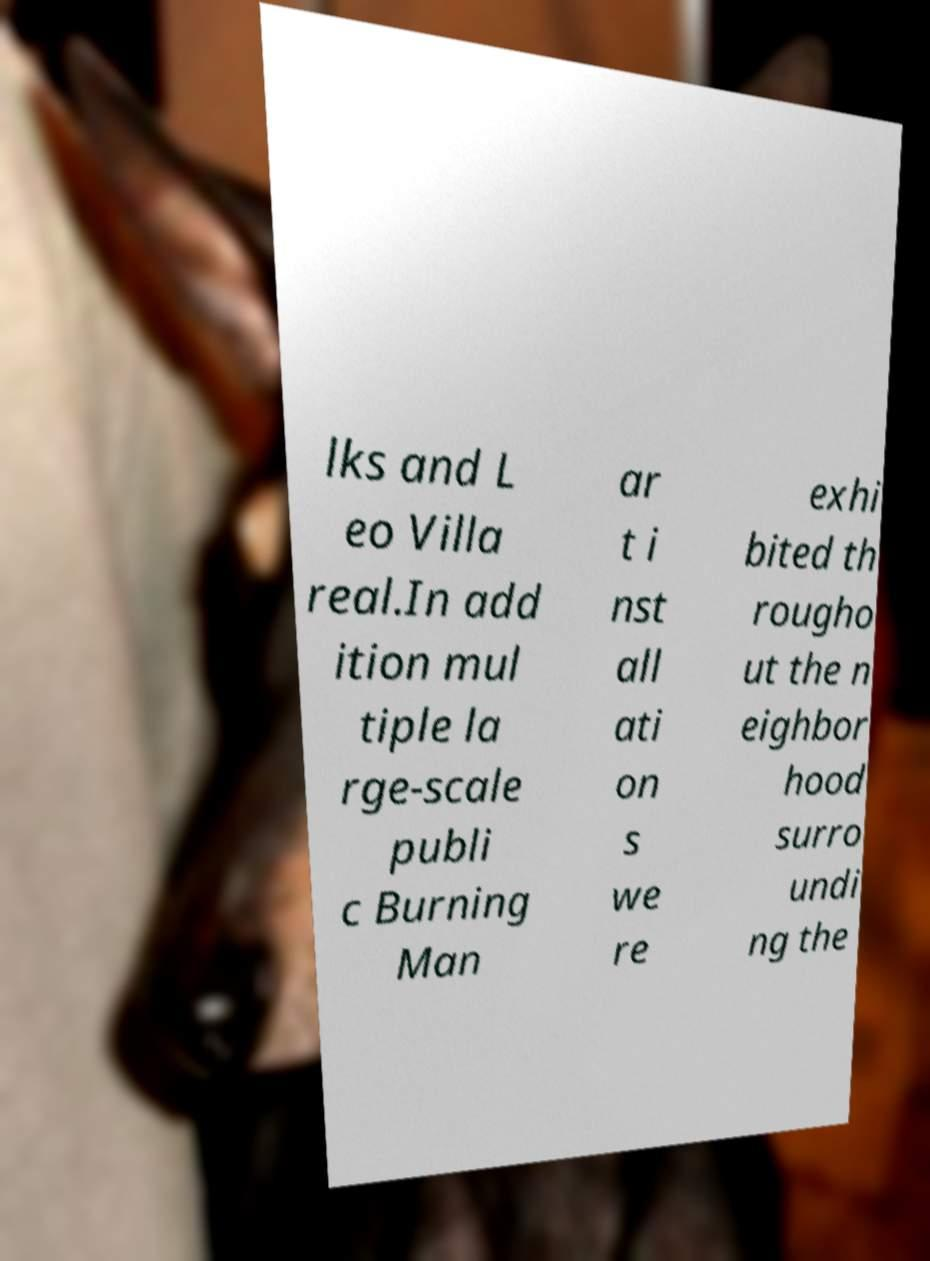Please identify and transcribe the text found in this image. lks and L eo Villa real.In add ition mul tiple la rge-scale publi c Burning Man ar t i nst all ati on s we re exhi bited th rougho ut the n eighbor hood surro undi ng the 